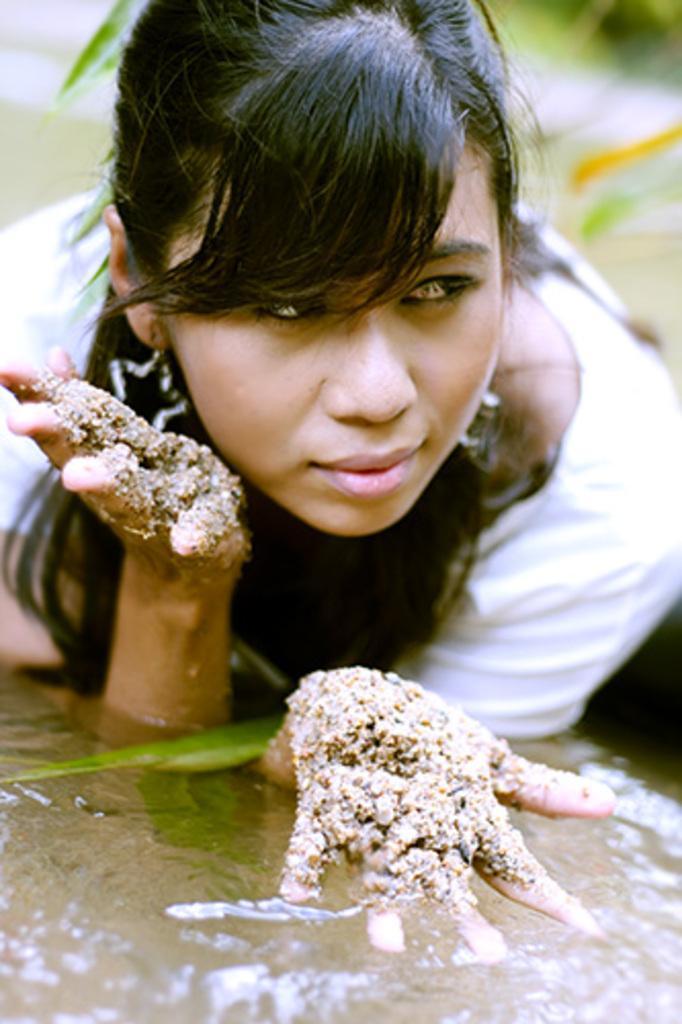Describe this image in one or two sentences. A woman is lying in the water, this is mud. 